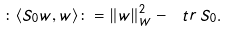<formula> <loc_0><loc_0><loc_500><loc_500>\colon \langle S _ { 0 } w , w \rangle \colon = \| w \| _ { W } ^ { 2 } - \ t r \, S _ { 0 } .</formula> 